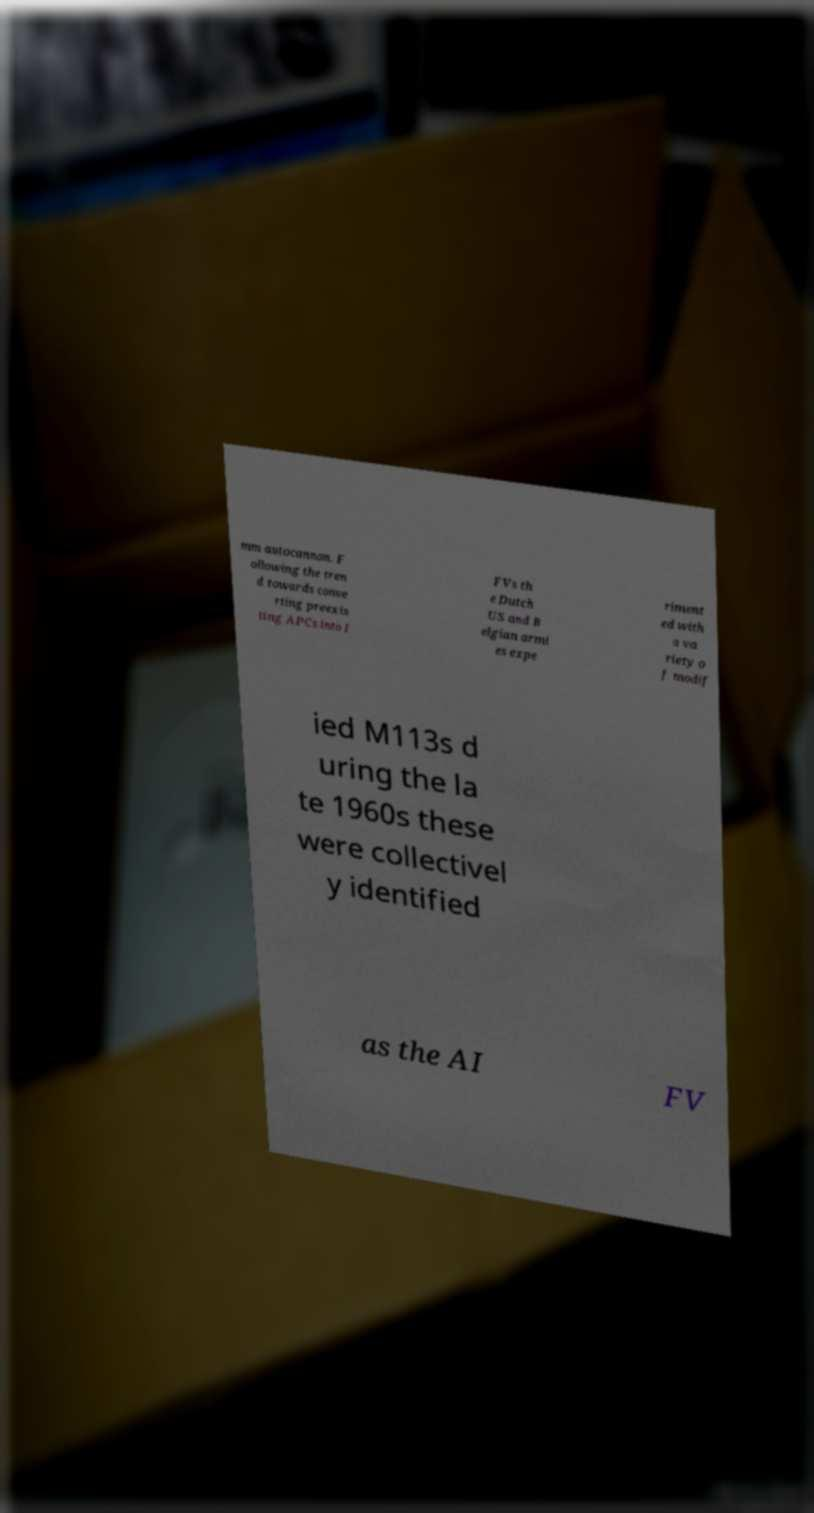Could you extract and type out the text from this image? mm autocannon. F ollowing the tren d towards conve rting preexis ting APCs into I FVs th e Dutch US and B elgian armi es expe riment ed with a va riety o f modif ied M113s d uring the la te 1960s these were collectivel y identified as the AI FV 